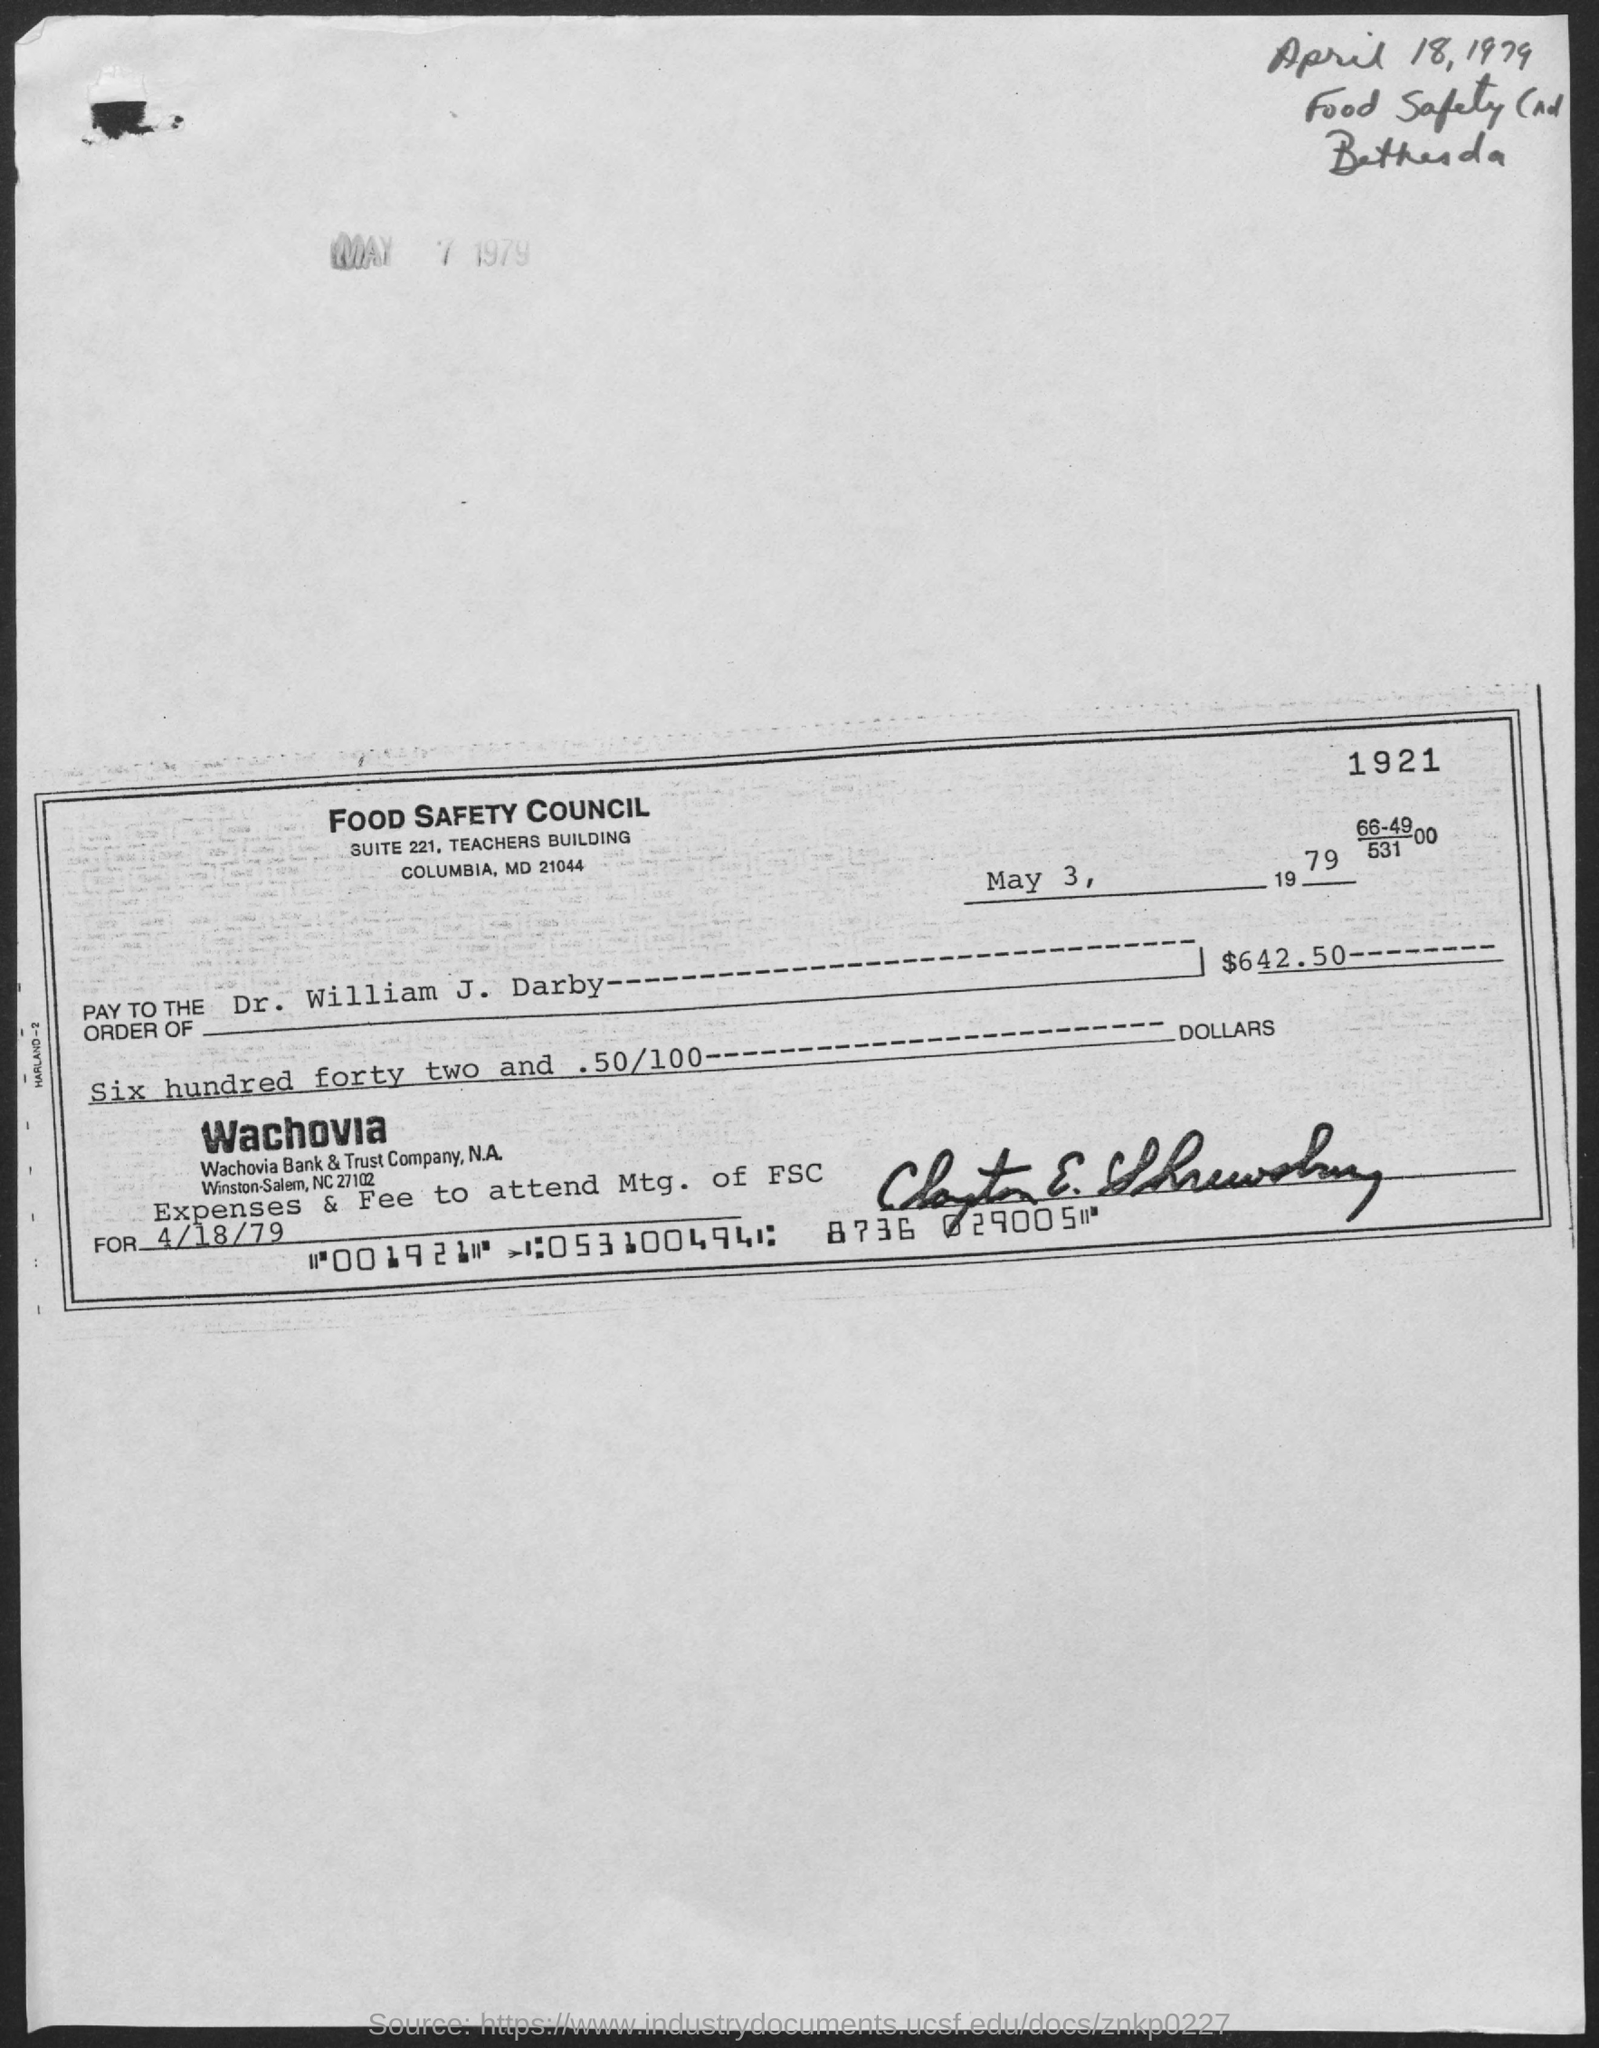What is the date on the check?
Ensure brevity in your answer.  May 3, 1979. What is the amount?
Provide a succinct answer. $642 50. 